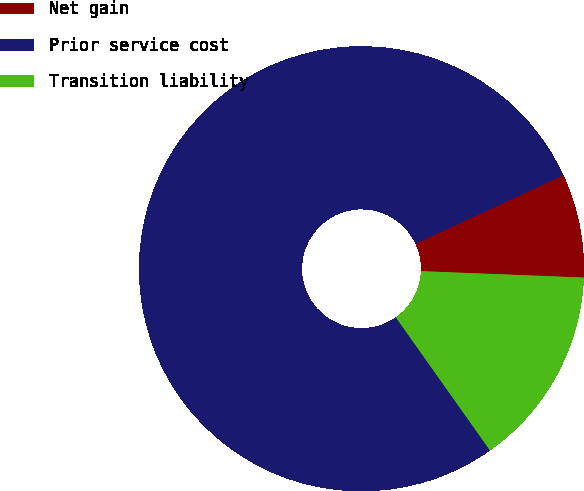Convert chart to OTSL. <chart><loc_0><loc_0><loc_500><loc_500><pie_chart><fcel>Net gain<fcel>Prior service cost<fcel>Transition liability<nl><fcel>7.54%<fcel>77.89%<fcel>14.57%<nl></chart> 